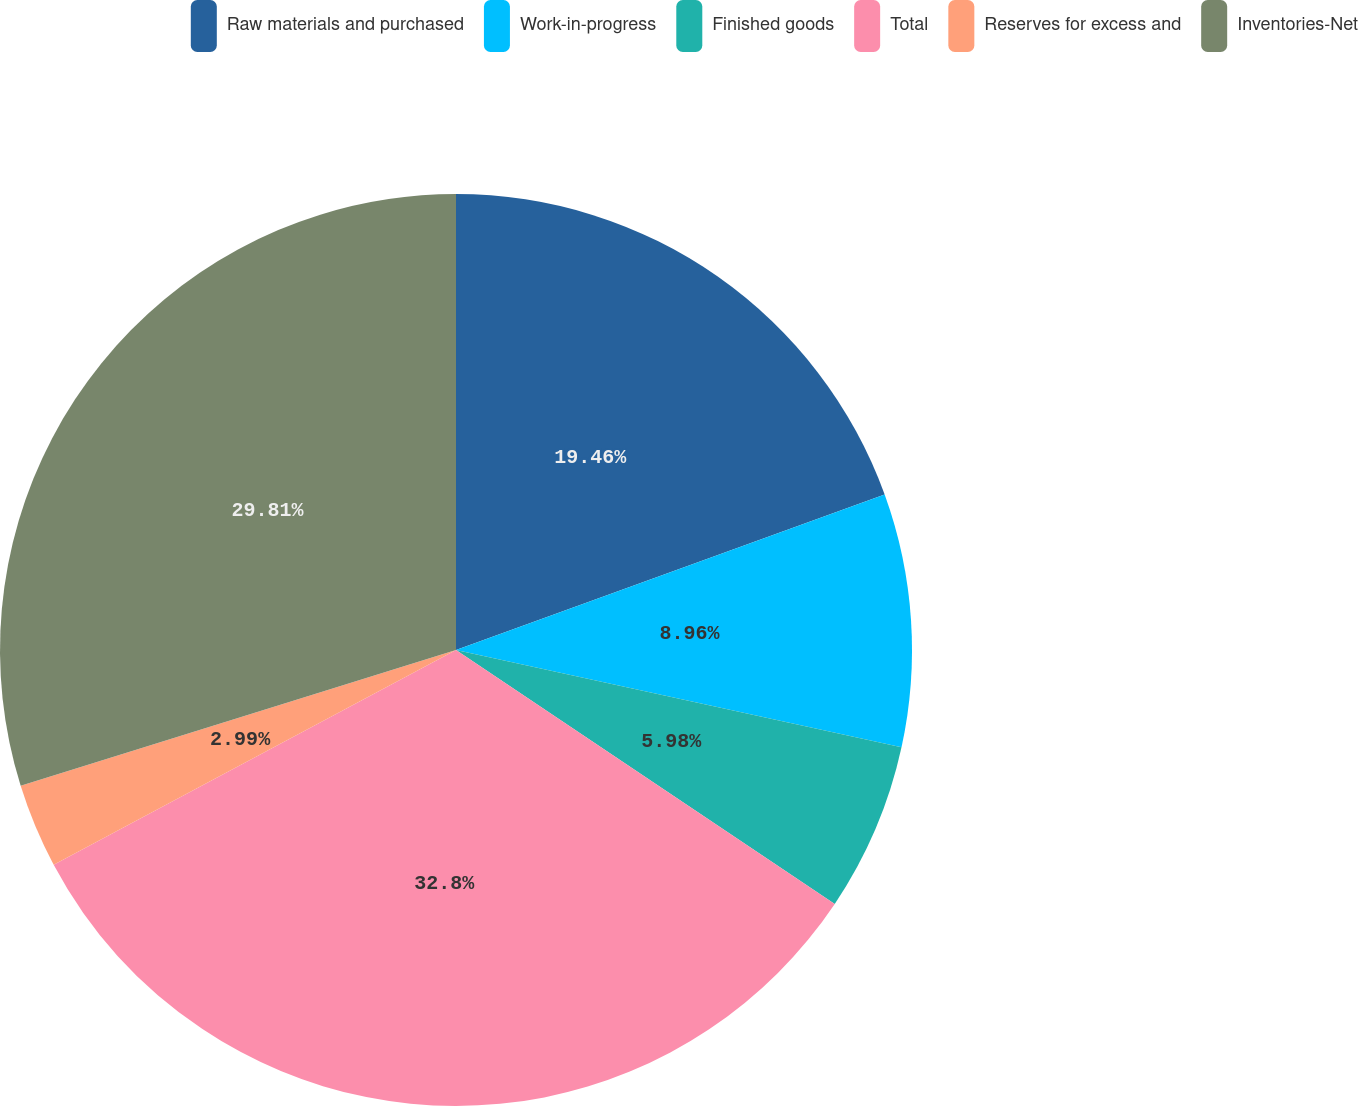Convert chart. <chart><loc_0><loc_0><loc_500><loc_500><pie_chart><fcel>Raw materials and purchased<fcel>Work-in-progress<fcel>Finished goods<fcel>Total<fcel>Reserves for excess and<fcel>Inventories-Net<nl><fcel>19.46%<fcel>8.96%<fcel>5.98%<fcel>32.8%<fcel>2.99%<fcel>29.81%<nl></chart> 